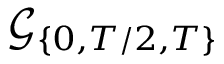<formula> <loc_0><loc_0><loc_500><loc_500>\mathcal { G } _ { \{ 0 , T / 2 , T \} }</formula> 